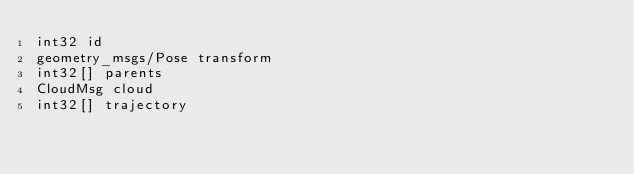Convert code to text. <code><loc_0><loc_0><loc_500><loc_500><_C_>int32 id
geometry_msgs/Pose transform
int32[] parents
CloudMsg cloud
int32[] trajectory
</code> 